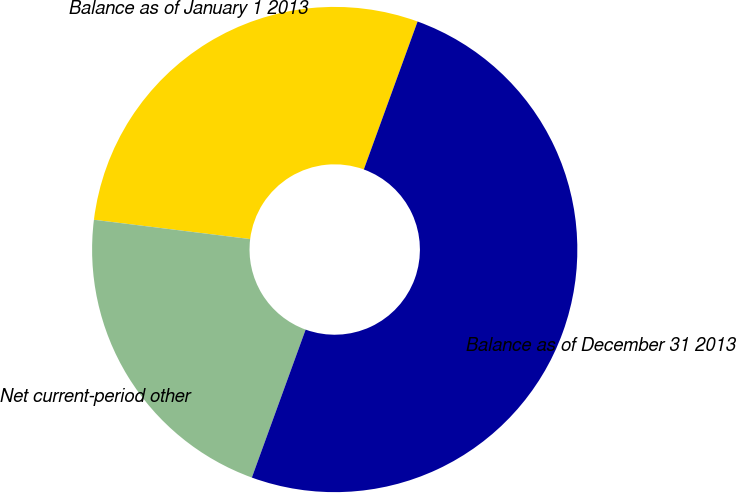Convert chart to OTSL. <chart><loc_0><loc_0><loc_500><loc_500><pie_chart><fcel>Balance as of January 1 2013<fcel>Net current-period other<fcel>Balance as of December 31 2013<nl><fcel>28.59%<fcel>21.41%<fcel>50.0%<nl></chart> 